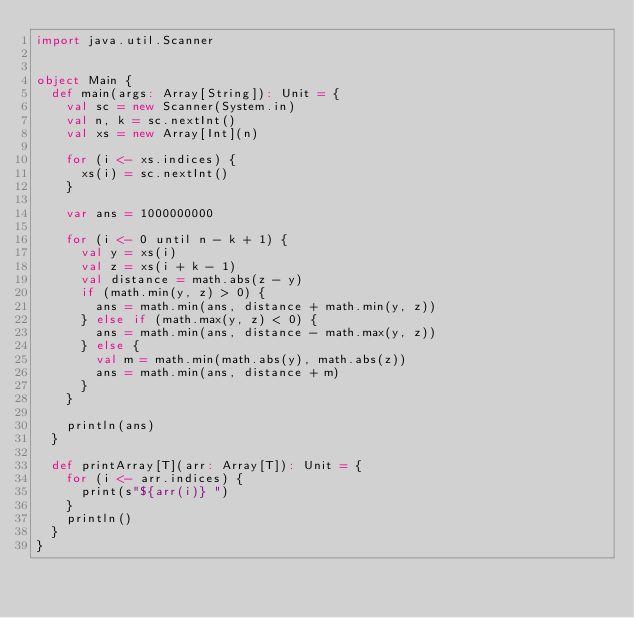<code> <loc_0><loc_0><loc_500><loc_500><_Scala_>import java.util.Scanner


object Main {
  def main(args: Array[String]): Unit = {
    val sc = new Scanner(System.in)
    val n, k = sc.nextInt()
    val xs = new Array[Int](n)
    
    for (i <- xs.indices) {
      xs(i) = sc.nextInt()
    }
    
    var ans = 1000000000
    
    for (i <- 0 until n - k + 1) {
      val y = xs(i)
      val z = xs(i + k - 1)
      val distance = math.abs(z - y)
      if (math.min(y, z) > 0) {
        ans = math.min(ans, distance + math.min(y, z))
      } else if (math.max(y, z) < 0) {
        ans = math.min(ans, distance - math.max(y, z))
      } else {
        val m = math.min(math.abs(y), math.abs(z))
        ans = math.min(ans, distance + m)
      }
    }
    
    println(ans)
  }
  
  def printArray[T](arr: Array[T]): Unit = {
    for (i <- arr.indices) {
      print(s"${arr(i)} ")
    }
    println()
  }
}
</code> 